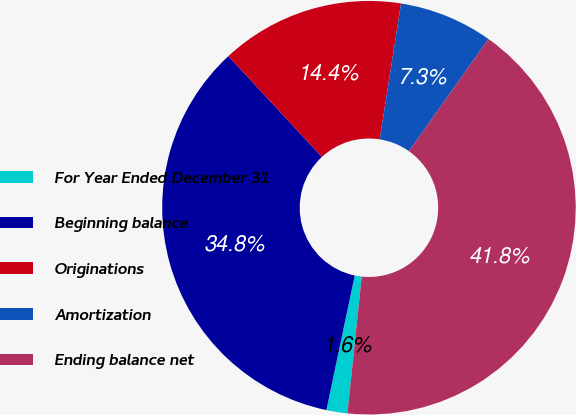Convert chart. <chart><loc_0><loc_0><loc_500><loc_500><pie_chart><fcel>For Year Ended December 31<fcel>Beginning balance<fcel>Originations<fcel>Amortization<fcel>Ending balance net<nl><fcel>1.64%<fcel>34.8%<fcel>14.38%<fcel>7.33%<fcel>41.85%<nl></chart> 